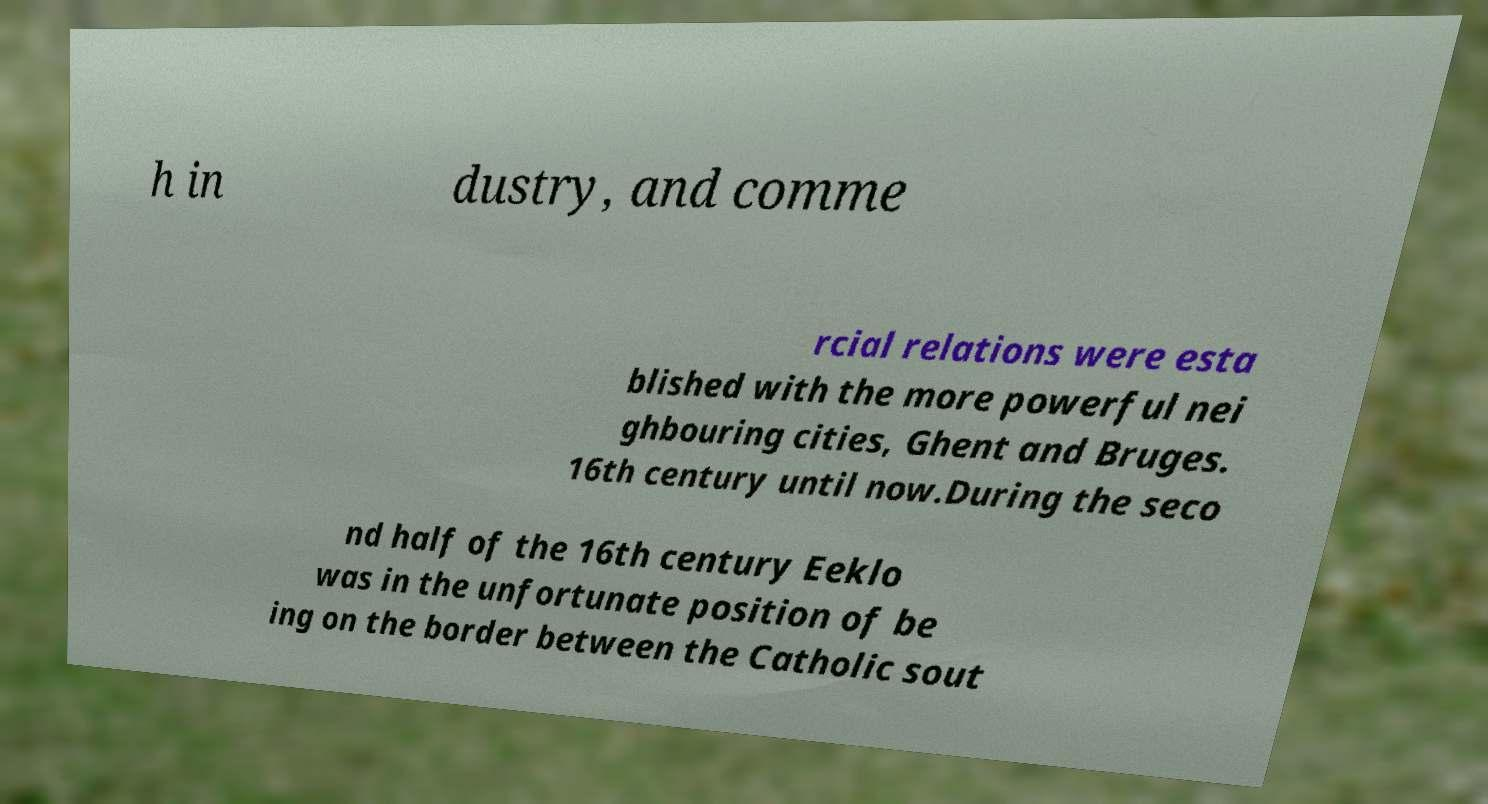Could you extract and type out the text from this image? h in dustry, and comme rcial relations were esta blished with the more powerful nei ghbouring cities, Ghent and Bruges. 16th century until now.During the seco nd half of the 16th century Eeklo was in the unfortunate position of be ing on the border between the Catholic sout 